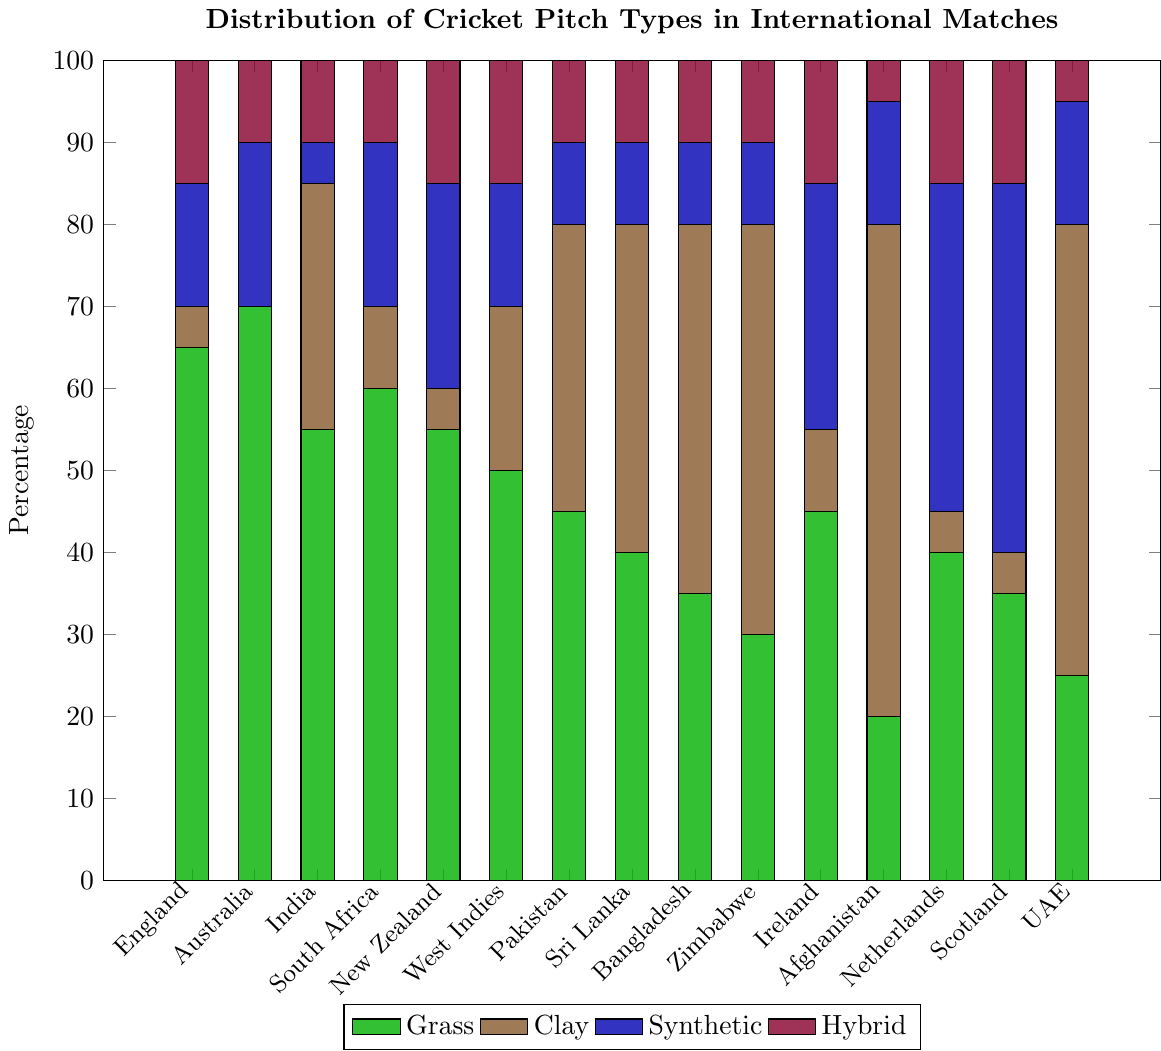Which country uses grass pitches the most? According to the bar chart, Australia has the tallest green bar, representing the percentage of grass pitches used, which is 70%.
Answer: Australia Which country has the highest percentage of clay pitches? The tallest brown bar in the chart represents the percentage of clay pitches, which belongs to Afghanistan at 60%.
Answer: Afghanistan Compare the usage of synthetic pitches in the Netherlands and Scotland. Which country uses it more? By observing the height of the blue bars for the Netherlands and Scotland, the Netherlands has a 40% usage, while Scotland has a 45% usage, indicating Scotland uses more synthetic pitches.
Answer: Scotland What is the combined percentage of hybrid pitches used in England and South Africa? Adding the purple bars for hybrid pitches in England (15%) and South Africa (10%) gives a total of 25%.
Answer: 25% Among the countries listed, which one uses hybrid pitches the least? The shortest purple bar represents hybrid pitch usage, which is Afghanistan and UAE both at 5%.
Answer: Afghanistan and UAE Calculate the average percentage of grass pitches used across India, Pakistan, and Sri Lanka. Summing the percentages of grass pitches in India (55%), Pakistan (45%), and Sri Lanka (40%) gives 140%. The average is 140/3, which equals approximately 46.67%.
Answer: 46.67% Which country has a higher combined percentage of clay and synthetic pitches, Bangladesh or Ireland? For Bangladesh: Clay (45%) + Synthetic (10%) = 55%. For Ireland: Clay (10%) + Synthetic (30%) = 40%. Therefore, Bangladesh has a higher combined usage.
Answer: Bangladesh Which country has the lowest percentage of grass pitches? The shortest green bar corresponds to Afghanistan, which has 20% of grass pitches.
Answer: Afghanistan Compare the usage of synthetic and hybrid pitches in New Zealand. Which type is used more? New Zealand has a blue bar for synthetic pitches at 25% and a purple bar for hybrid pitches at 15%, indicating more usage of synthetic pitches.
Answer: Synthetic pitches Among all the listed countries, which one has the most balanced distribution of the four pitch types? Sri Lanka has 40% clay, 40% grass, 10% synthetic, and 10% hybrid, showing a more balanced type distribution than other countries.
Answer: Sri Lanka 